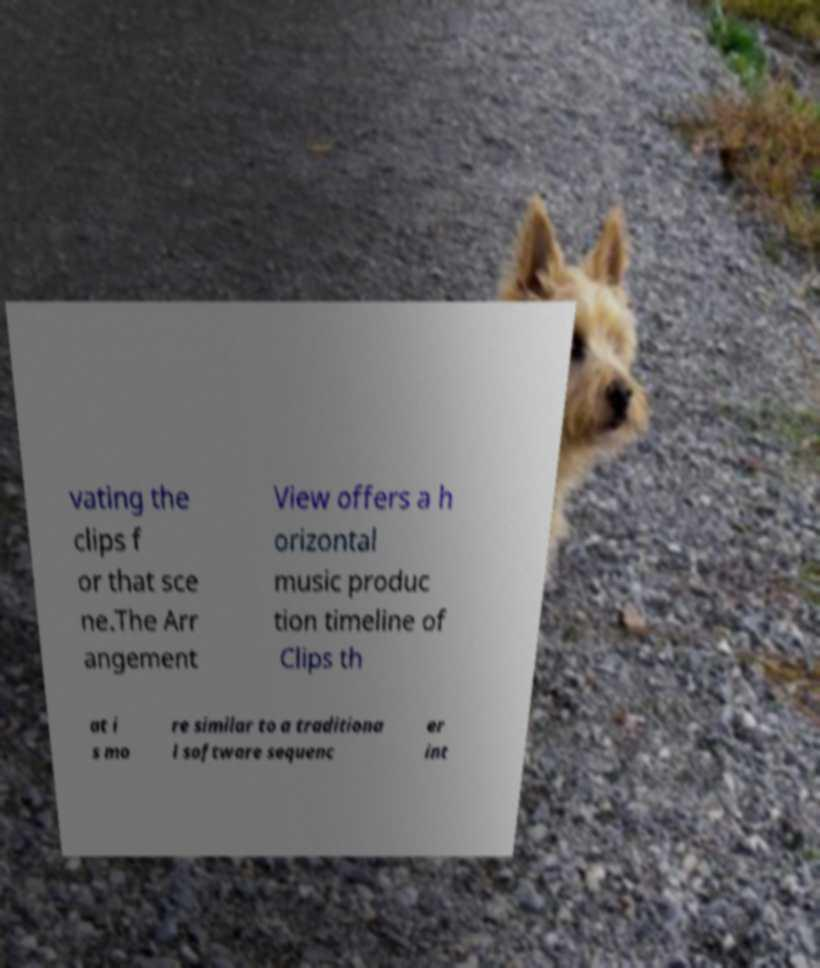I need the written content from this picture converted into text. Can you do that? vating the clips f or that sce ne.The Arr angement View offers a h orizontal music produc tion timeline of Clips th at i s mo re similar to a traditiona l software sequenc er int 